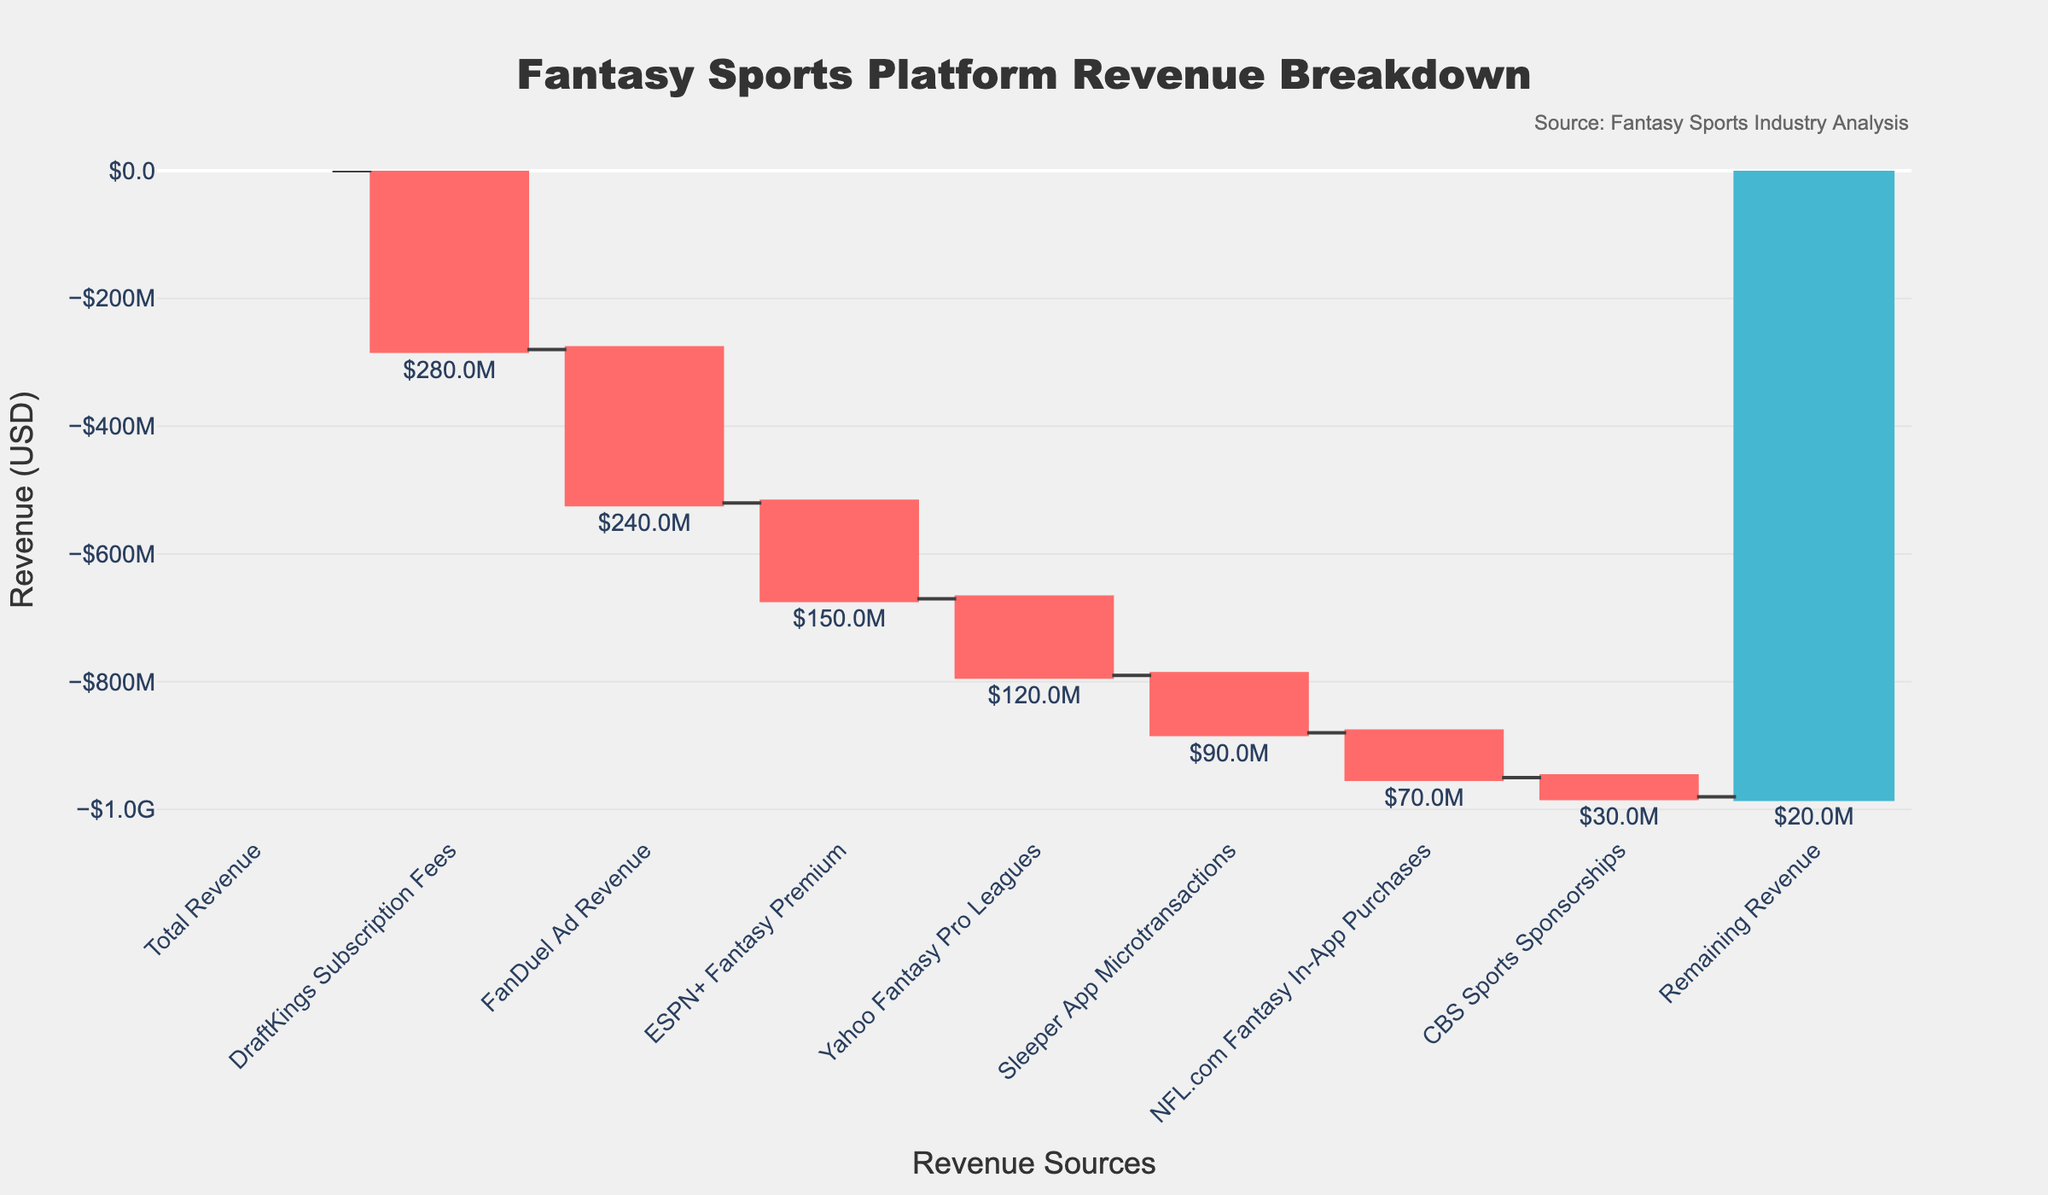What's the total revenue shown in the chart? The total revenue is displayed as the first data point in the chart and labeled as "Total Revenue". The value is indicated on the y-axis and the bar's text as well.
Answer: $1,000,000,000 Which revenue source has the most negative impact? The most negative impact corresponds to the longest red bar which represents the largest decrease. "DraftKings Subscription Fees" has the largest negative value.
Answer: DraftKings Subscription Fees What is the final remaining revenue after accounting for all other sources? The "Remaining Revenue" is the last bar on the chart. It signifies the total revenue after accounting for all other increases and decreases.
Answer: $20,000,000 How much revenue is lost due to FanDuel Ad Revenue and ESPN+ Fantasy Premium combined? Add the negative values of "FanDuel Ad Revenue" (-$240M) and "ESPN+ Fantasy Premium" (-$150M). The combined loss is $240M + $150M = $390M.
Answer: $390,000,000 Which platform contributes the least to the negative revenue impact? The smallest red bar represents the least negative revenue impact, which belongs to "CBS Sports Sponsorships".
Answer: CBS Sports Sponsorships How much revenue is generated by Sleeper App Microtransactions? The revenue generated is shown by the text label next to the "Sleeper App Microtransactions" bar. It's written as '$90M'.
Answer: $90,000,000 What is the difference between the total revenue and the summed negative impacts of listed sources? Subtract the sum of all negative impacts from the total revenue. Total negative impacts = $280M (DraftKings) + $240M (FanDuel) + $150M (ESPN+) + $120M (Yahoo) + $90M (Sleeper) + $70M (NFL.com) + $30M (CBS Sports) = $980M. Difference = $1,000M - $980M
Answer: $20,000,000 Between Yahoo Fantasy Pro Leagues and NFL.com Fantasy In-App Purchases, which has a higher revenue impact? Compare the heights of their respective bars. "Yahoo Fantasy Pro Leagues" has a higher negative impact with a value of -$120M compared to -$70M for "NFL.com Fantasy In-App Purchases".
Answer: Yahoo Fantasy Pro Leagues Which revenues listed account for decreases in total revenue? The red bars indicate decreases. They include "DraftKings Subscription Fees," "FanDuel Ad Revenue," "ESPN+ Fantasy Premium," "Yahoo Fantasy Pro Leagues," "Sleeper App Microtransactions," "NFL.com Fantasy In-App Purchases," and "CBS Sports Sponsorships."
Answer: DraftKings Subscription Fees, FanDuel Ad Revenue, ESPN+ Fantasy Premium, Yahoo Fantasy Pro Leagues, Sleeper App Microtransactions, NFL.com Fantasy In-App Purchases, CBS Sports Sponsorships 